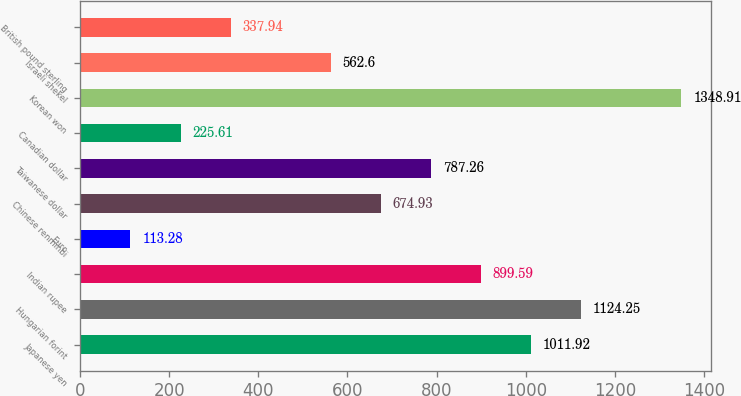Convert chart to OTSL. <chart><loc_0><loc_0><loc_500><loc_500><bar_chart><fcel>Japanese yen<fcel>Hungarian forint<fcel>Indian rupee<fcel>Euro<fcel>Chinese renminbi<fcel>Taiwanese dollar<fcel>Canadian dollar<fcel>Korean won<fcel>Israeli shekel<fcel>British pound sterling<nl><fcel>1011.92<fcel>1124.25<fcel>899.59<fcel>113.28<fcel>674.93<fcel>787.26<fcel>225.61<fcel>1348.91<fcel>562.6<fcel>337.94<nl></chart> 